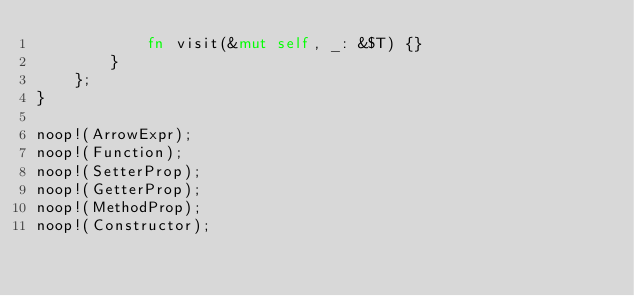Convert code to text. <code><loc_0><loc_0><loc_500><loc_500><_Rust_>            fn visit(&mut self, _: &$T) {}
        }
    };
}

noop!(ArrowExpr);
noop!(Function);
noop!(SetterProp);
noop!(GetterProp);
noop!(MethodProp);
noop!(Constructor);
</code> 